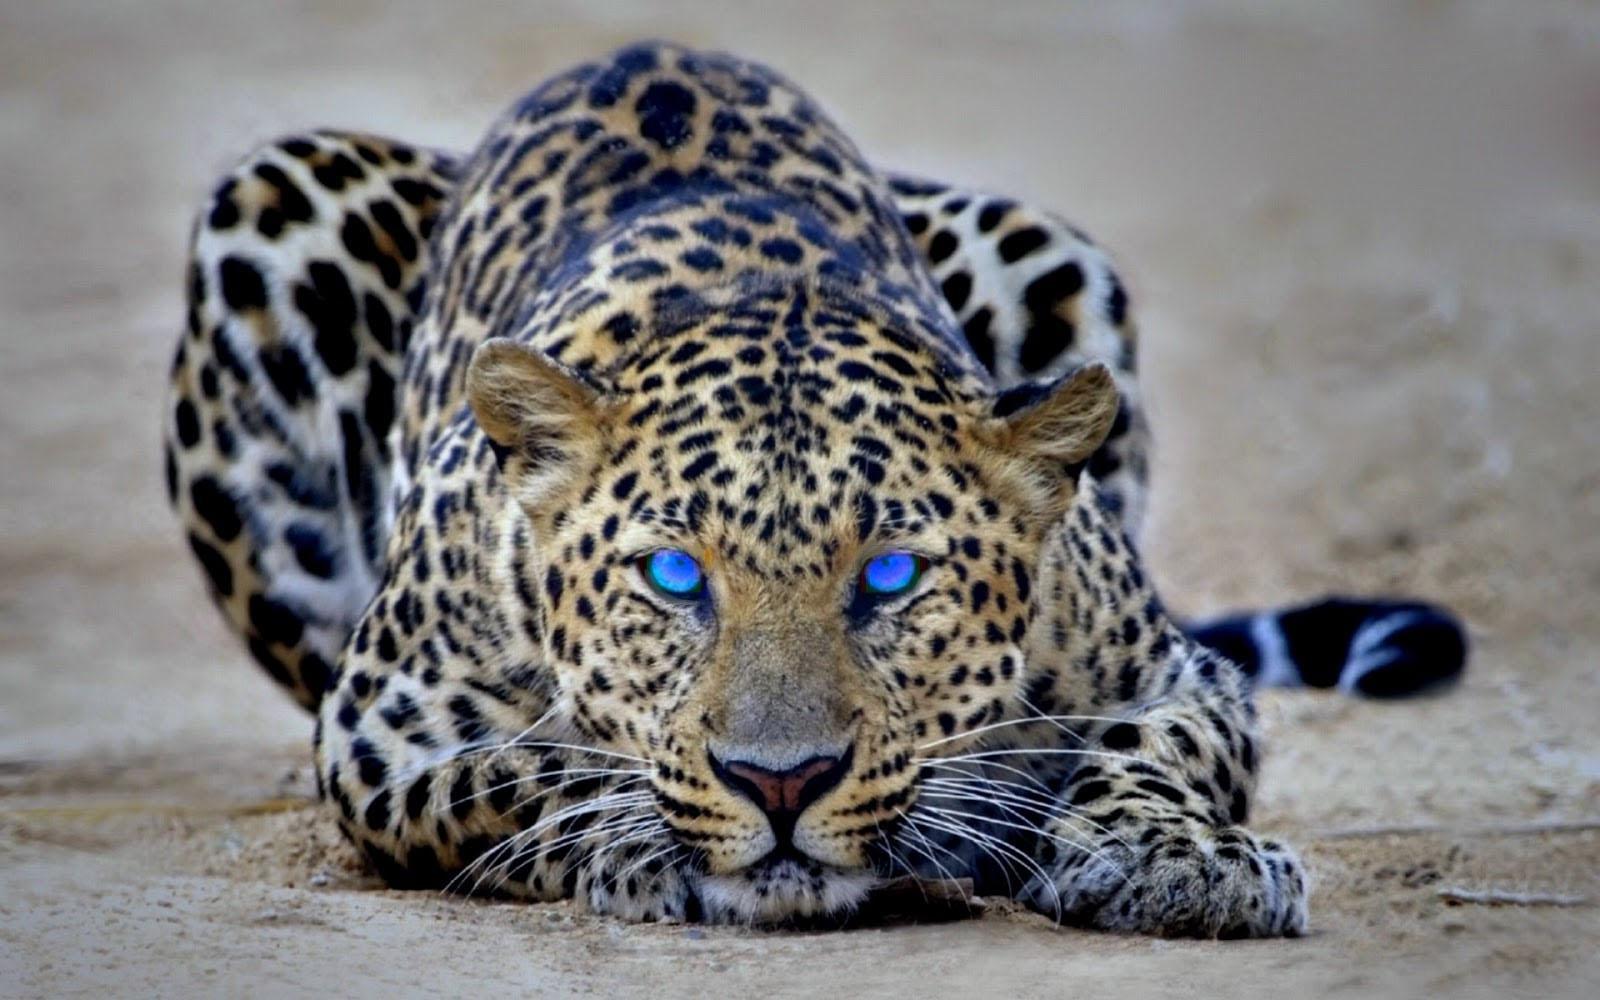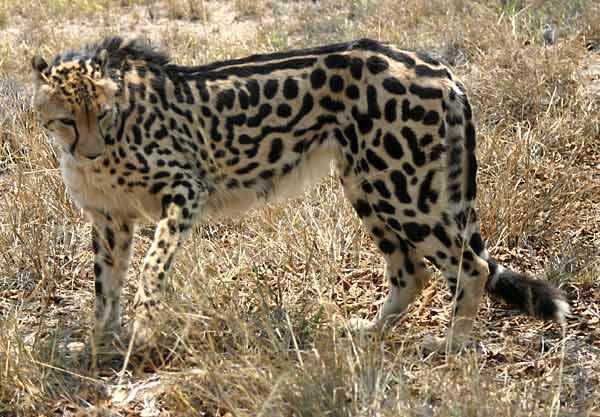The first image is the image on the left, the second image is the image on the right. Analyze the images presented: Is the assertion "The leopard in the image on the left is sitting with her kittens." valid? Answer yes or no. No. The first image is the image on the left, the second image is the image on the right. Assess this claim about the two images: "The left image includes exactly one spotted wild cat.". Correct or not? Answer yes or no. Yes. 